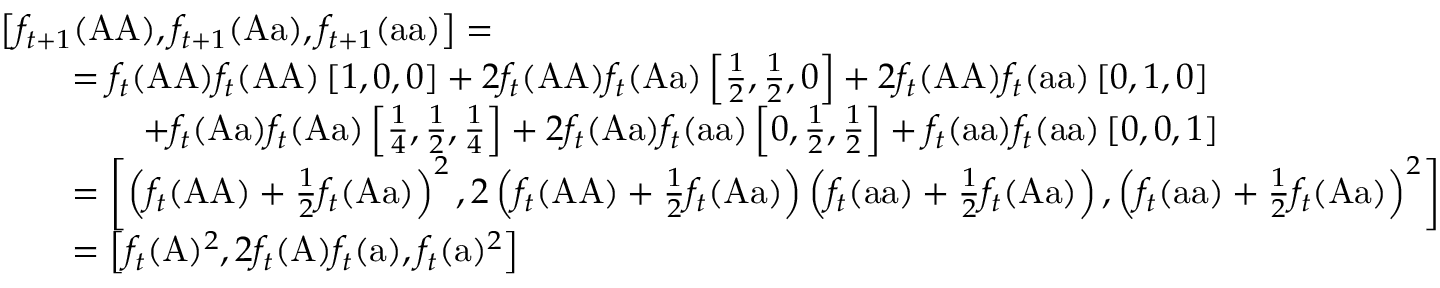Convert formula to latex. <formula><loc_0><loc_0><loc_500><loc_500>{ \begin{array} { r l } & { \left [ f _ { t + 1 } ( { A A } ) , f _ { t + 1 } ( { A a } ) , f _ { t + 1 } ( { a a } ) \right ] = } \\ & { \quad = f _ { t } ( { A A } ) f _ { t } ( { A A } ) \left [ 1 , 0 , 0 \right ] + 2 f _ { t } ( { A A } ) f _ { t } ( { A a } ) \left [ { \frac { 1 } { 2 } } , { \frac { 1 } { 2 } } , 0 \right ] + 2 f _ { t } ( { A A } ) f _ { t } ( { a a } ) \left [ 0 , 1 , 0 \right ] } \\ & { \quad + f _ { t } ( { A a } ) f _ { t } ( { A a } ) \left [ { \frac { 1 } { 4 } } , { \frac { 1 } { 2 } } , { \frac { 1 } { 4 } } \right ] + 2 f _ { t } ( { A a } ) f _ { t } ( { a a } ) \left [ 0 , { \frac { 1 } { 2 } } , { \frac { 1 } { 2 } } \right ] + f _ { t } ( { a a } ) f _ { t } ( { a a } ) \left [ 0 , 0 , 1 \right ] } \\ & { \quad = \left [ \left ( f _ { t } ( { A A } ) + { \frac { 1 } { 2 } } f _ { t } ( { A a } ) \right ) ^ { 2 } , 2 \left ( f _ { t } ( { A A } ) + { \frac { 1 } { 2 } } f _ { t } ( { A a } ) \right ) \left ( f _ { t } ( { a a } ) + { \frac { 1 } { 2 } } f _ { t } ( { A a } ) \right ) , \left ( f _ { t } ( { a a } ) + { \frac { 1 } { 2 } } f _ { t } ( { A a } ) \right ) ^ { 2 } \right ] } \\ & { \quad = \left [ f _ { t } ( { A } ) ^ { 2 } , 2 f _ { t } ( { A } ) f _ { t } ( { a } ) , f _ { t } ( { a } ) ^ { 2 } \right ] } \end{array} }</formula> 